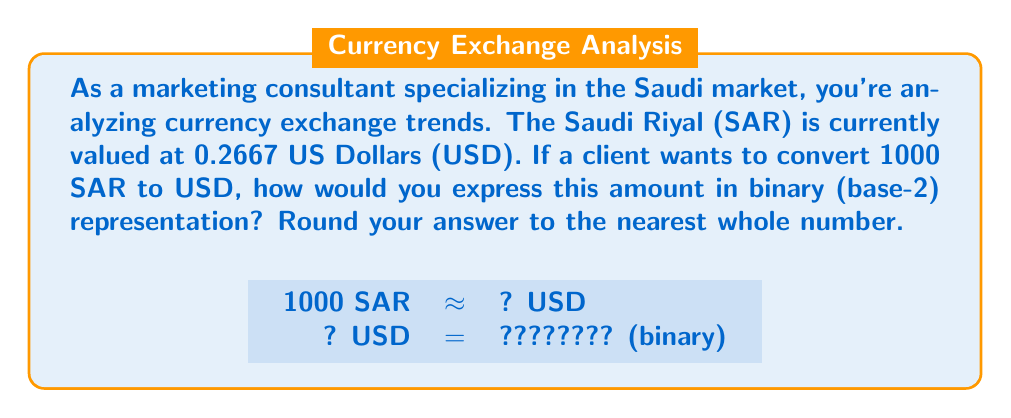Can you answer this question? Let's approach this step-by-step:

1) First, we need to convert 1000 SAR to USD:
   $$1000 \text{ SAR} \times 0.2667 \text{ USD/SAR} = 266.7 \text{ USD}$$

2) Rounding to the nearest whole number:
   $$266.7 \text{ USD} \approx 267 \text{ USD}$$

3) Now, we need to convert 267 (base-10) to binary (base-2). We can do this by repeatedly dividing by 2 and keeping track of the remainders:

   $$\begin{align}
   267 \div 2 &= 133 \text{ remainder } 1 \\
   133 \div 2 &= 66 \text{ remainder } 1 \\
   66 \div 2 &= 33 \text{ remainder } 0 \\
   33 \div 2 &= 16 \text{ remainder } 1 \\
   16 \div 2 &= 8 \text{ remainder } 0 \\
   8 \div 2 &= 4 \text{ remainder } 0 \\
   4 \div 2 &= 2 \text{ remainder } 0 \\
   2 \div 2 &= 1 \text{ remainder } 0 \\
   1 \div 2 &= 0 \text{ remainder } 1
   \end{align}$$

4) Reading the remainders from bottom to top gives us the binary representation:
   $$267_{10} = 100001011_2$$

Thus, 1000 SAR, when converted to USD and represented in binary, is approximately 100001011 in base-2.
Answer: $100001011_2$ 